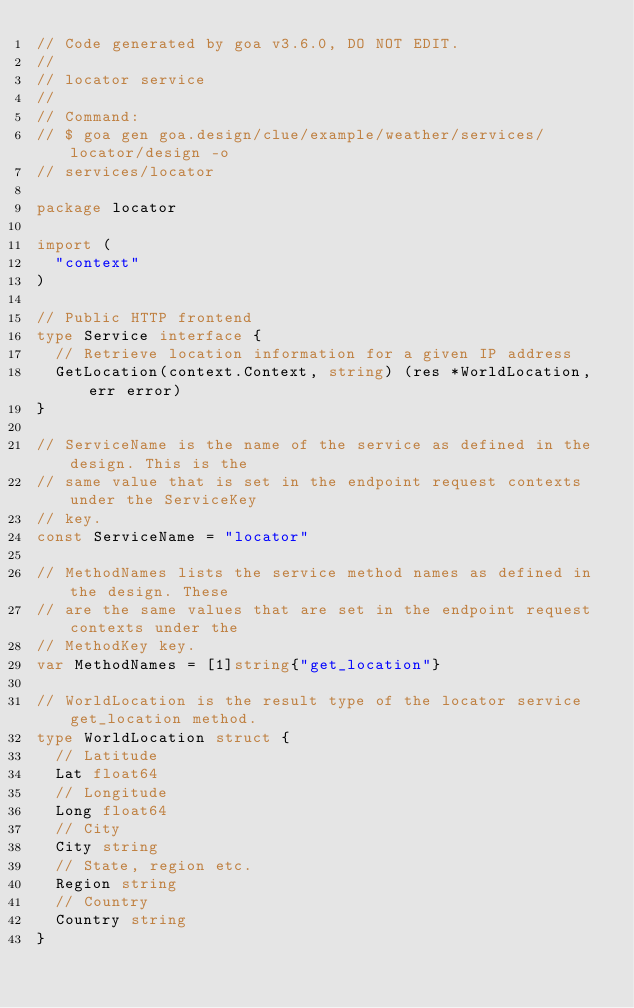<code> <loc_0><loc_0><loc_500><loc_500><_Go_>// Code generated by goa v3.6.0, DO NOT EDIT.
//
// locator service
//
// Command:
// $ goa gen goa.design/clue/example/weather/services/locator/design -o
// services/locator

package locator

import (
	"context"
)

// Public HTTP frontend
type Service interface {
	// Retrieve location information for a given IP address
	GetLocation(context.Context, string) (res *WorldLocation, err error)
}

// ServiceName is the name of the service as defined in the design. This is the
// same value that is set in the endpoint request contexts under the ServiceKey
// key.
const ServiceName = "locator"

// MethodNames lists the service method names as defined in the design. These
// are the same values that are set in the endpoint request contexts under the
// MethodKey key.
var MethodNames = [1]string{"get_location"}

// WorldLocation is the result type of the locator service get_location method.
type WorldLocation struct {
	// Latitude
	Lat float64
	// Longitude
	Long float64
	// City
	City string
	// State, region etc.
	Region string
	// Country
	Country string
}
</code> 